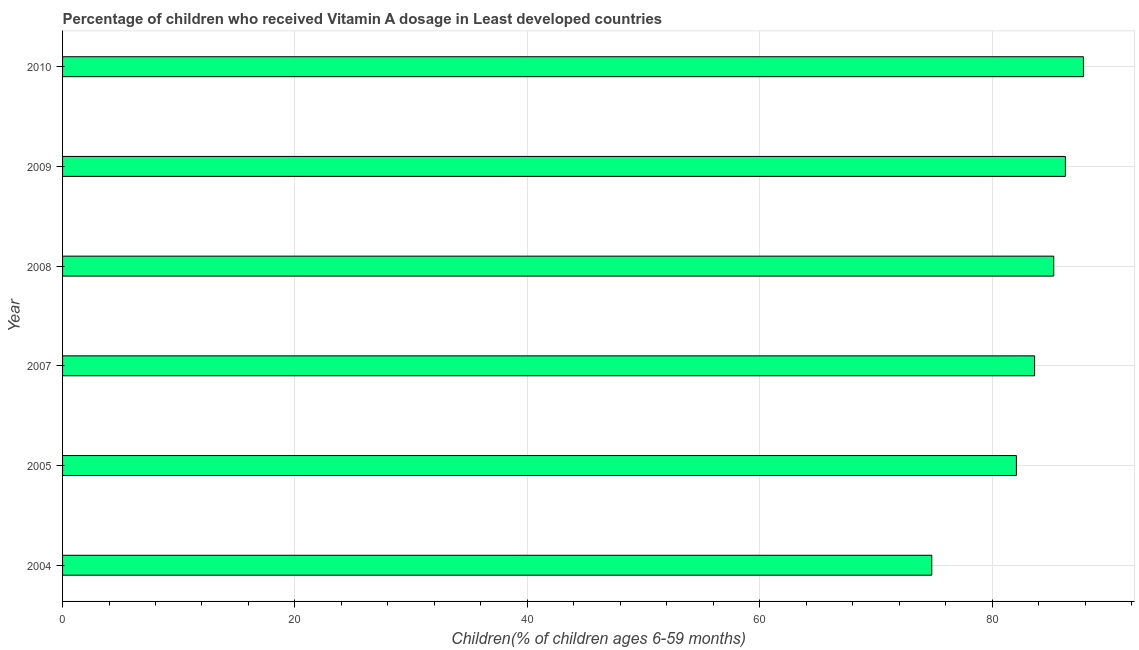What is the title of the graph?
Keep it short and to the point. Percentage of children who received Vitamin A dosage in Least developed countries. What is the label or title of the X-axis?
Provide a short and direct response. Children(% of children ages 6-59 months). What is the label or title of the Y-axis?
Give a very brief answer. Year. What is the vitamin a supplementation coverage rate in 2005?
Ensure brevity in your answer.  82.1. Across all years, what is the maximum vitamin a supplementation coverage rate?
Ensure brevity in your answer.  87.87. Across all years, what is the minimum vitamin a supplementation coverage rate?
Your answer should be very brief. 74.81. What is the sum of the vitamin a supplementation coverage rate?
Your response must be concise. 500.05. What is the difference between the vitamin a supplementation coverage rate in 2005 and 2009?
Keep it short and to the point. -4.22. What is the average vitamin a supplementation coverage rate per year?
Offer a terse response. 83.34. What is the median vitamin a supplementation coverage rate?
Give a very brief answer. 84.49. In how many years, is the vitamin a supplementation coverage rate greater than 4 %?
Give a very brief answer. 6. Is the vitamin a supplementation coverage rate in 2004 less than that in 2005?
Your response must be concise. Yes. Is the difference between the vitamin a supplementation coverage rate in 2005 and 2008 greater than the difference between any two years?
Your answer should be compact. No. What is the difference between the highest and the second highest vitamin a supplementation coverage rate?
Offer a terse response. 1.55. Is the sum of the vitamin a supplementation coverage rate in 2004 and 2010 greater than the maximum vitamin a supplementation coverage rate across all years?
Offer a very short reply. Yes. What is the difference between the highest and the lowest vitamin a supplementation coverage rate?
Make the answer very short. 13.05. In how many years, is the vitamin a supplementation coverage rate greater than the average vitamin a supplementation coverage rate taken over all years?
Offer a very short reply. 4. What is the difference between two consecutive major ticks on the X-axis?
Your response must be concise. 20. Are the values on the major ticks of X-axis written in scientific E-notation?
Keep it short and to the point. No. What is the Children(% of children ages 6-59 months) in 2004?
Your response must be concise. 74.81. What is the Children(% of children ages 6-59 months) of 2005?
Your answer should be compact. 82.1. What is the Children(% of children ages 6-59 months) in 2007?
Your answer should be compact. 83.66. What is the Children(% of children ages 6-59 months) in 2008?
Make the answer very short. 85.31. What is the Children(% of children ages 6-59 months) of 2009?
Make the answer very short. 86.31. What is the Children(% of children ages 6-59 months) of 2010?
Make the answer very short. 87.87. What is the difference between the Children(% of children ages 6-59 months) in 2004 and 2005?
Provide a short and direct response. -7.28. What is the difference between the Children(% of children ages 6-59 months) in 2004 and 2007?
Provide a short and direct response. -8.85. What is the difference between the Children(% of children ages 6-59 months) in 2004 and 2008?
Make the answer very short. -10.5. What is the difference between the Children(% of children ages 6-59 months) in 2004 and 2009?
Offer a terse response. -11.5. What is the difference between the Children(% of children ages 6-59 months) in 2004 and 2010?
Your answer should be very brief. -13.05. What is the difference between the Children(% of children ages 6-59 months) in 2005 and 2007?
Offer a terse response. -1.57. What is the difference between the Children(% of children ages 6-59 months) in 2005 and 2008?
Offer a very short reply. -3.21. What is the difference between the Children(% of children ages 6-59 months) in 2005 and 2009?
Give a very brief answer. -4.22. What is the difference between the Children(% of children ages 6-59 months) in 2005 and 2010?
Ensure brevity in your answer.  -5.77. What is the difference between the Children(% of children ages 6-59 months) in 2007 and 2008?
Your answer should be very brief. -1.65. What is the difference between the Children(% of children ages 6-59 months) in 2007 and 2009?
Offer a very short reply. -2.65. What is the difference between the Children(% of children ages 6-59 months) in 2007 and 2010?
Give a very brief answer. -4.2. What is the difference between the Children(% of children ages 6-59 months) in 2008 and 2009?
Keep it short and to the point. -1. What is the difference between the Children(% of children ages 6-59 months) in 2008 and 2010?
Offer a terse response. -2.56. What is the difference between the Children(% of children ages 6-59 months) in 2009 and 2010?
Provide a short and direct response. -1.55. What is the ratio of the Children(% of children ages 6-59 months) in 2004 to that in 2005?
Keep it short and to the point. 0.91. What is the ratio of the Children(% of children ages 6-59 months) in 2004 to that in 2007?
Ensure brevity in your answer.  0.89. What is the ratio of the Children(% of children ages 6-59 months) in 2004 to that in 2008?
Your response must be concise. 0.88. What is the ratio of the Children(% of children ages 6-59 months) in 2004 to that in 2009?
Your response must be concise. 0.87. What is the ratio of the Children(% of children ages 6-59 months) in 2004 to that in 2010?
Provide a succinct answer. 0.85. What is the ratio of the Children(% of children ages 6-59 months) in 2005 to that in 2007?
Offer a terse response. 0.98. What is the ratio of the Children(% of children ages 6-59 months) in 2005 to that in 2009?
Give a very brief answer. 0.95. What is the ratio of the Children(% of children ages 6-59 months) in 2005 to that in 2010?
Your answer should be compact. 0.93. What is the ratio of the Children(% of children ages 6-59 months) in 2007 to that in 2008?
Keep it short and to the point. 0.98. What is the ratio of the Children(% of children ages 6-59 months) in 2007 to that in 2009?
Offer a terse response. 0.97. What is the ratio of the Children(% of children ages 6-59 months) in 2008 to that in 2009?
Provide a short and direct response. 0.99. What is the ratio of the Children(% of children ages 6-59 months) in 2008 to that in 2010?
Make the answer very short. 0.97. What is the ratio of the Children(% of children ages 6-59 months) in 2009 to that in 2010?
Offer a terse response. 0.98. 